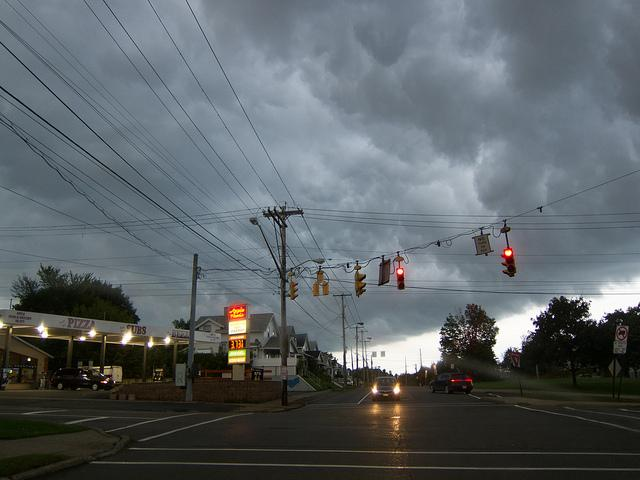What type of station is in view?

Choices:
A) bus
B) gas
C) fire
D) train gas 